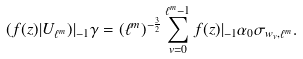<formula> <loc_0><loc_0><loc_500><loc_500>( f ( z ) | U _ { \ell ^ { m } } ) | _ { - 1 } \gamma = ( \ell ^ { m } ) ^ { - \frac { 3 } { 2 } } \sum _ { v = 0 } ^ { \ell ^ { m } - 1 } f ( z ) | _ { - 1 } \alpha _ { 0 } \sigma _ { w _ { v } , \ell ^ { m } } .</formula> 